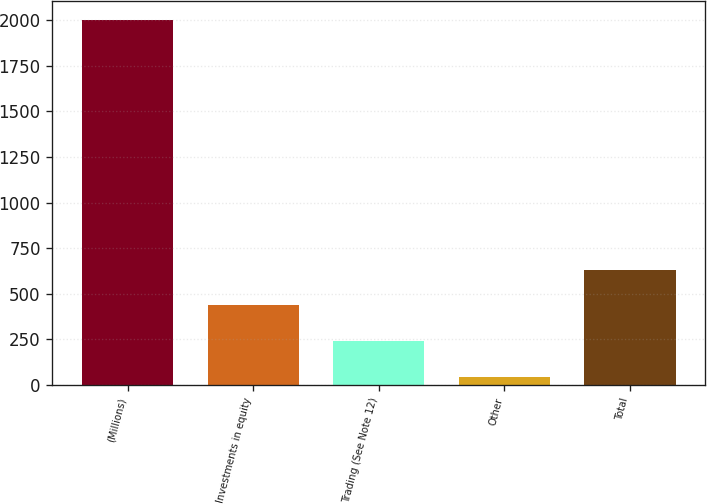Convert chart. <chart><loc_0><loc_0><loc_500><loc_500><bar_chart><fcel>(Millions)<fcel>Investments in equity<fcel>Trading (See Note 12)<fcel>Other<fcel>Total<nl><fcel>2004<fcel>436<fcel>240<fcel>44<fcel>632<nl></chart> 